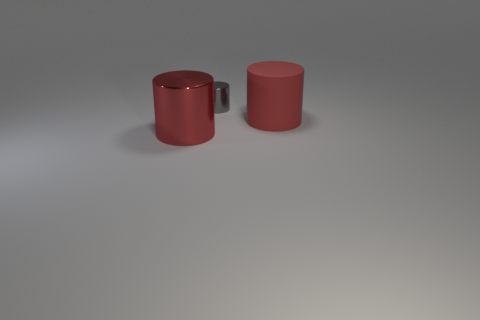Add 1 cylinders. How many objects exist? 4 Add 3 tiny cylinders. How many tiny cylinders are left? 4 Add 1 tiny blue rubber spheres. How many tiny blue rubber spheres exist? 1 Subtract 0 blue balls. How many objects are left? 3 Subtract all tiny green balls. Subtract all rubber cylinders. How many objects are left? 2 